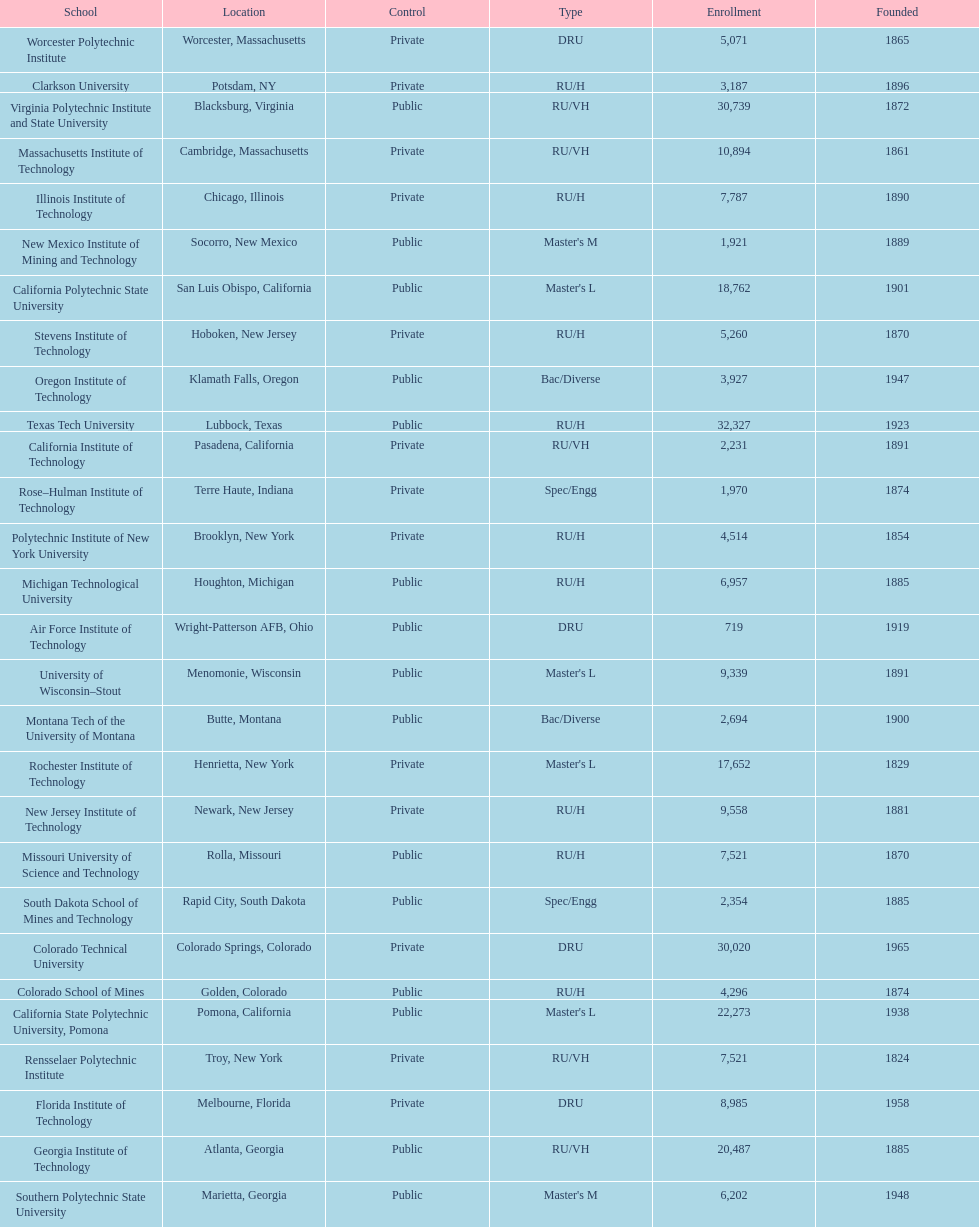How many of the universities were located in california? 3. Write the full table. {'header': ['School', 'Location', 'Control', 'Type', 'Enrollment', 'Founded'], 'rows': [['Worcester Polytechnic Institute', 'Worcester, Massachusetts', 'Private', 'DRU', '5,071', '1865'], ['Clarkson University', 'Potsdam, NY', 'Private', 'RU/H', '3,187', '1896'], ['Virginia Polytechnic Institute and State University', 'Blacksburg, Virginia', 'Public', 'RU/VH', '30,739', '1872'], ['Massachusetts Institute of Technology', 'Cambridge, Massachusetts', 'Private', 'RU/VH', '10,894', '1861'], ['Illinois Institute of Technology', 'Chicago, Illinois', 'Private', 'RU/H', '7,787', '1890'], ['New Mexico Institute of Mining and Technology', 'Socorro, New Mexico', 'Public', "Master's M", '1,921', '1889'], ['California Polytechnic State University', 'San Luis Obispo, California', 'Public', "Master's L", '18,762', '1901'], ['Stevens Institute of Technology', 'Hoboken, New Jersey', 'Private', 'RU/H', '5,260', '1870'], ['Oregon Institute of Technology', 'Klamath Falls, Oregon', 'Public', 'Bac/Diverse', '3,927', '1947'], ['Texas Tech University', 'Lubbock, Texas', 'Public', 'RU/H', '32,327', '1923'], ['California Institute of Technology', 'Pasadena, California', 'Private', 'RU/VH', '2,231', '1891'], ['Rose–Hulman Institute of Technology', 'Terre Haute, Indiana', 'Private', 'Spec/Engg', '1,970', '1874'], ['Polytechnic Institute of New York University', 'Brooklyn, New York', 'Private', 'RU/H', '4,514', '1854'], ['Michigan Technological University', 'Houghton, Michigan', 'Public', 'RU/H', '6,957', '1885'], ['Air Force Institute of Technology', 'Wright-Patterson AFB, Ohio', 'Public', 'DRU', '719', '1919'], ['University of Wisconsin–Stout', 'Menomonie, Wisconsin', 'Public', "Master's L", '9,339', '1891'], ['Montana Tech of the University of Montana', 'Butte, Montana', 'Public', 'Bac/Diverse', '2,694', '1900'], ['Rochester Institute of Technology', 'Henrietta, New York', 'Private', "Master's L", '17,652', '1829'], ['New Jersey Institute of Technology', 'Newark, New Jersey', 'Private', 'RU/H', '9,558', '1881'], ['Missouri University of Science and Technology', 'Rolla, Missouri', 'Public', 'RU/H', '7,521', '1870'], ['South Dakota School of Mines and Technology', 'Rapid City, South Dakota', 'Public', 'Spec/Engg', '2,354', '1885'], ['Colorado Technical University', 'Colorado Springs, Colorado', 'Private', 'DRU', '30,020', '1965'], ['Colorado School of Mines', 'Golden, Colorado', 'Public', 'RU/H', '4,296', '1874'], ['California State Polytechnic University, Pomona', 'Pomona, California', 'Public', "Master's L", '22,273', '1938'], ['Rensselaer Polytechnic Institute', 'Troy, New York', 'Private', 'RU/VH', '7,521', '1824'], ['Florida Institute of Technology', 'Melbourne, Florida', 'Private', 'DRU', '8,985', '1958'], ['Georgia Institute of Technology', 'Atlanta, Georgia', 'Public', 'RU/VH', '20,487', '1885'], ['Southern Polytechnic State University', 'Marietta, Georgia', 'Public', "Master's M", '6,202', '1948']]} 